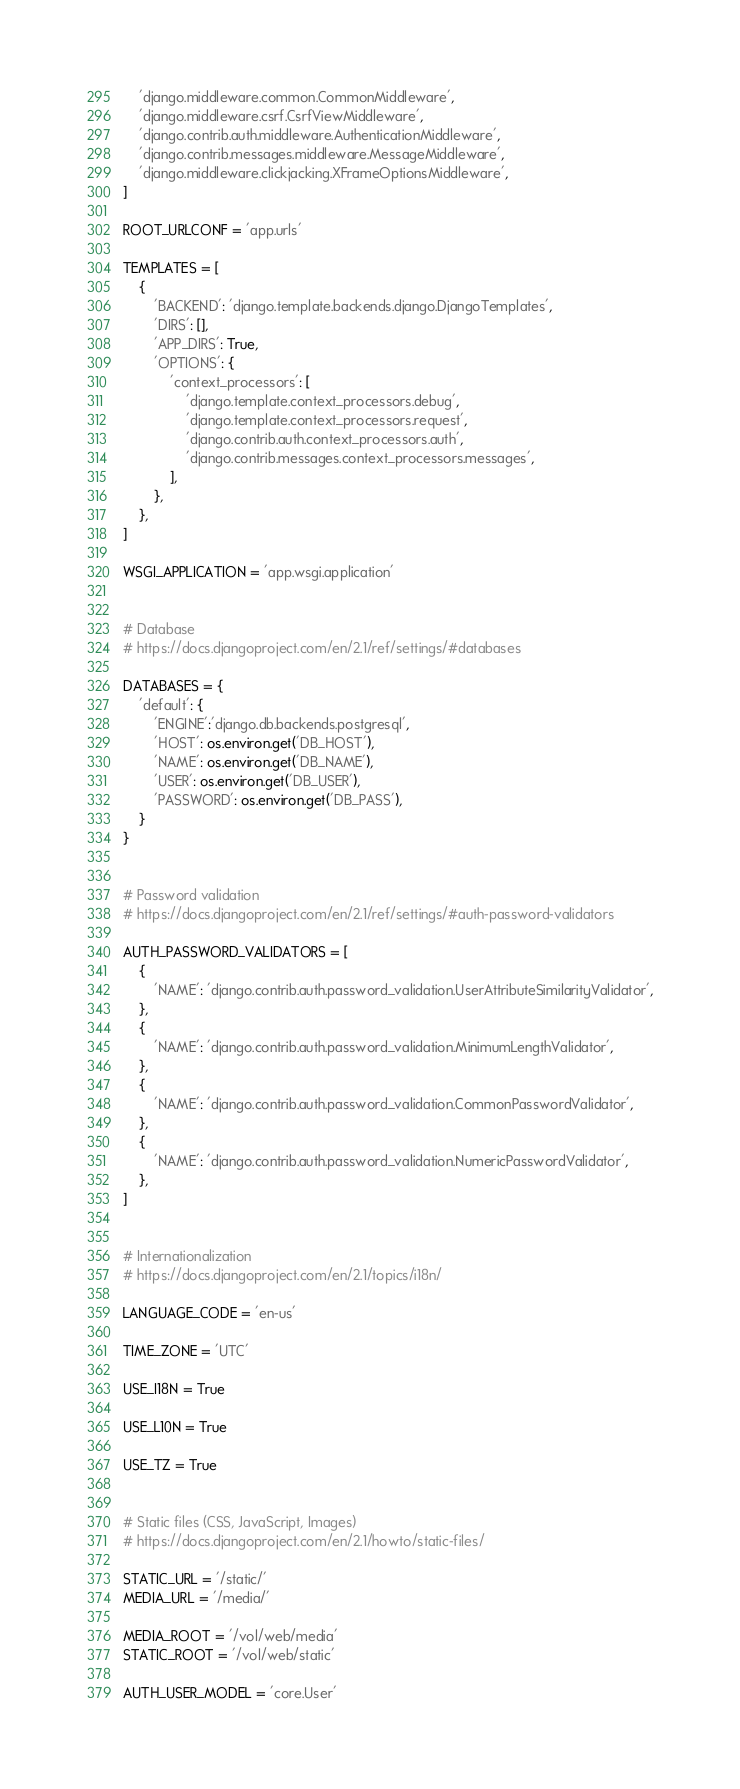Convert code to text. <code><loc_0><loc_0><loc_500><loc_500><_Python_>    'django.middleware.common.CommonMiddleware',
    'django.middleware.csrf.CsrfViewMiddleware',
    'django.contrib.auth.middleware.AuthenticationMiddleware',
    'django.contrib.messages.middleware.MessageMiddleware',
    'django.middleware.clickjacking.XFrameOptionsMiddleware',
]

ROOT_URLCONF = 'app.urls'

TEMPLATES = [
    {
        'BACKEND': 'django.template.backends.django.DjangoTemplates',
        'DIRS': [],
        'APP_DIRS': True,
        'OPTIONS': {
            'context_processors': [
                'django.template.context_processors.debug',
                'django.template.context_processors.request',
                'django.contrib.auth.context_processors.auth',
                'django.contrib.messages.context_processors.messages',
            ],
        },
    },
]

WSGI_APPLICATION = 'app.wsgi.application'


# Database
# https://docs.djangoproject.com/en/2.1/ref/settings/#databases

DATABASES = {
    'default': {
        'ENGINE':'django.db.backends.postgresql',
        'HOST': os.environ.get('DB_HOST'),
        'NAME': os.environ.get('DB_NAME'),
        'USER': os.environ.get('DB_USER'),
        'PASSWORD': os.environ.get('DB_PASS'),
    }
}


# Password validation
# https://docs.djangoproject.com/en/2.1/ref/settings/#auth-password-validators

AUTH_PASSWORD_VALIDATORS = [
    {
        'NAME': 'django.contrib.auth.password_validation.UserAttributeSimilarityValidator',
    },
    {
        'NAME': 'django.contrib.auth.password_validation.MinimumLengthValidator',
    },
    {
        'NAME': 'django.contrib.auth.password_validation.CommonPasswordValidator',
    },
    {
        'NAME': 'django.contrib.auth.password_validation.NumericPasswordValidator',
    },
]


# Internationalization
# https://docs.djangoproject.com/en/2.1/topics/i18n/

LANGUAGE_CODE = 'en-us'

TIME_ZONE = 'UTC'

USE_I18N = True

USE_L10N = True

USE_TZ = True


# Static files (CSS, JavaScript, Images)
# https://docs.djangoproject.com/en/2.1/howto/static-files/

STATIC_URL = '/static/'
MEDIA_URL = '/media/'

MEDIA_ROOT = '/vol/web/media'
STATIC_ROOT = '/vol/web/static'

AUTH_USER_MODEL = 'core.User'
</code> 